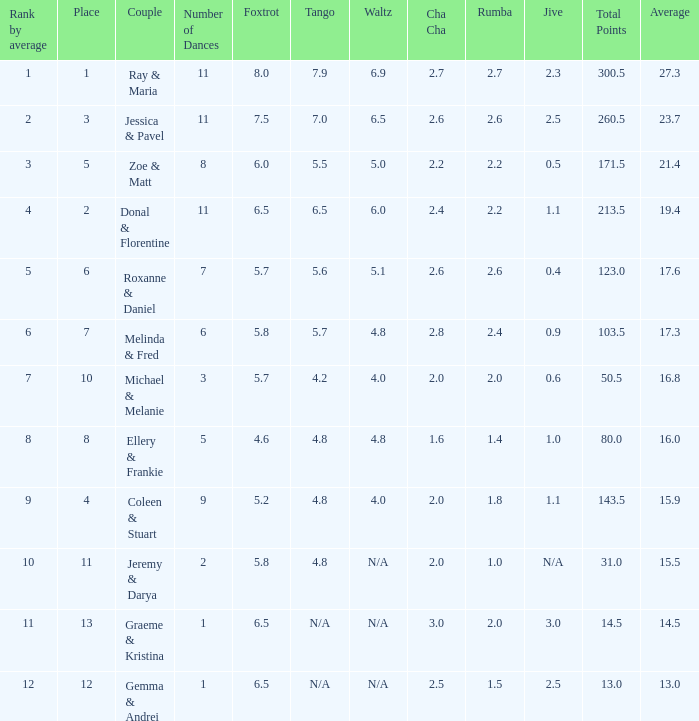If the total points is 50.5, what is the total number of dances? 1.0. 